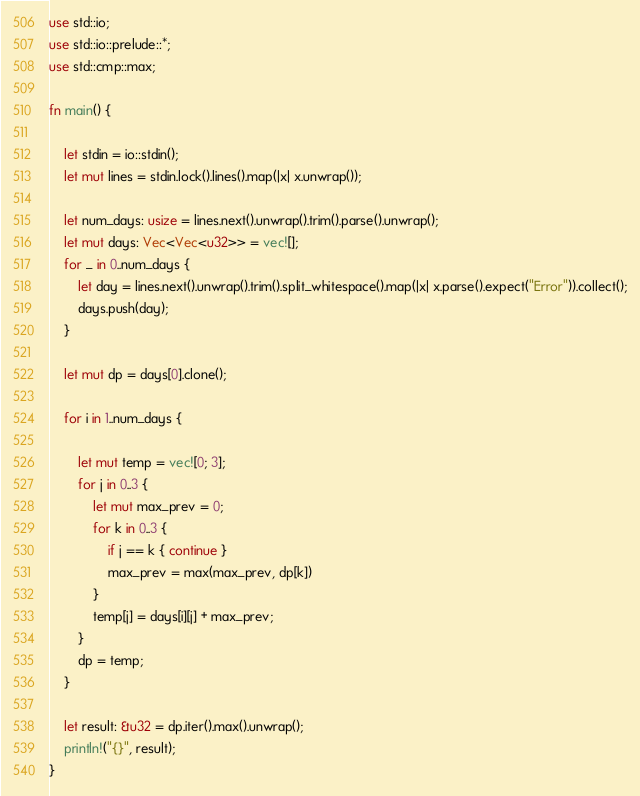<code> <loc_0><loc_0><loc_500><loc_500><_Rust_>
use std::io;
use std::io::prelude::*;
use std::cmp::max;

fn main() {

    let stdin = io::stdin();
    let mut lines = stdin.lock().lines().map(|x| x.unwrap());

    let num_days: usize = lines.next().unwrap().trim().parse().unwrap();
    let mut days: Vec<Vec<u32>> = vec![];
    for _ in 0..num_days {
        let day = lines.next().unwrap().trim().split_whitespace().map(|x| x.parse().expect("Error")).collect();
        days.push(day);
    }

    let mut dp = days[0].clone();

    for i in 1..num_days {

        let mut temp = vec![0; 3];
        for j in 0..3 {
            let mut max_prev = 0;
            for k in 0..3 {
                if j == k { continue }
                max_prev = max(max_prev, dp[k])
            }
            temp[j] = days[i][j] + max_prev;
        }
        dp = temp;
    }

    let result: &u32 = dp.iter().max().unwrap();
    println!("{}", result);
}</code> 